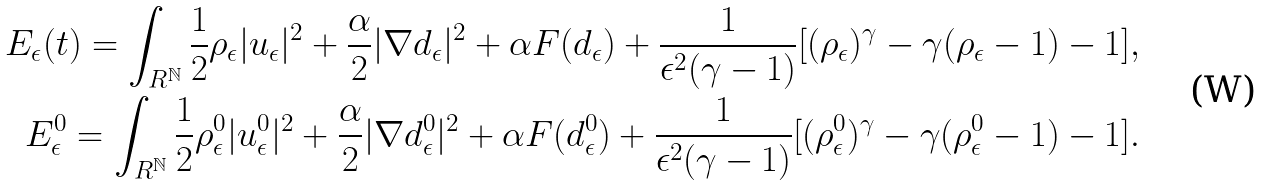Convert formula to latex. <formula><loc_0><loc_0><loc_500><loc_500>E _ { \epsilon } ( t ) = \int _ { R ^ { \mathbb { N } } } \frac { 1 } { 2 } \rho _ { \epsilon } | u _ { \epsilon } | ^ { 2 } + \frac { \alpha } { 2 } | \nabla d _ { \epsilon } | ^ { 2 } + \alpha F ( d _ { \epsilon } ) + \frac { 1 } { \epsilon ^ { 2 } ( \gamma - 1 ) } [ ( \rho _ { \epsilon } ) ^ { \gamma } - \gamma ( \rho _ { \epsilon } - 1 ) - 1 ] , \\ E _ { \epsilon } ^ { 0 } = \int _ { R ^ { \mathbb { N } } } \frac { 1 } { 2 } \rho _ { \epsilon } ^ { 0 } | u _ { \epsilon } ^ { 0 } | ^ { 2 } + \frac { \alpha } { 2 } | \nabla d _ { \epsilon } ^ { 0 } | ^ { 2 } + \alpha F ( d _ { \epsilon } ^ { 0 } ) + \frac { 1 } { \epsilon ^ { 2 } ( \gamma - 1 ) } [ ( \rho _ { \epsilon } ^ { 0 } ) ^ { \gamma } - \gamma ( \rho _ { \epsilon } ^ { 0 } - 1 ) - 1 ] .</formula> 